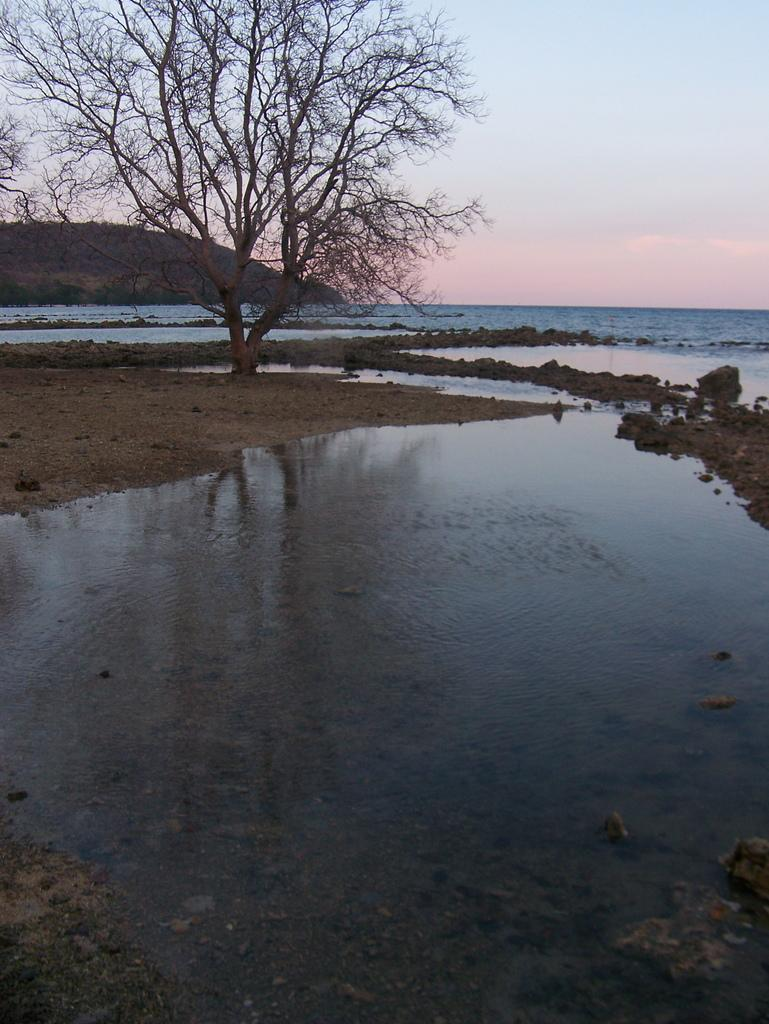What is visible in the image? Water is visible in the image. What can be seen on the left side of the image? There are trees on the left side of the image. How would you describe the sky in the image? The sky is cloudy in the image. Can you see any celery or cherries in the image? No, there are no celery or cherries present in the image. 